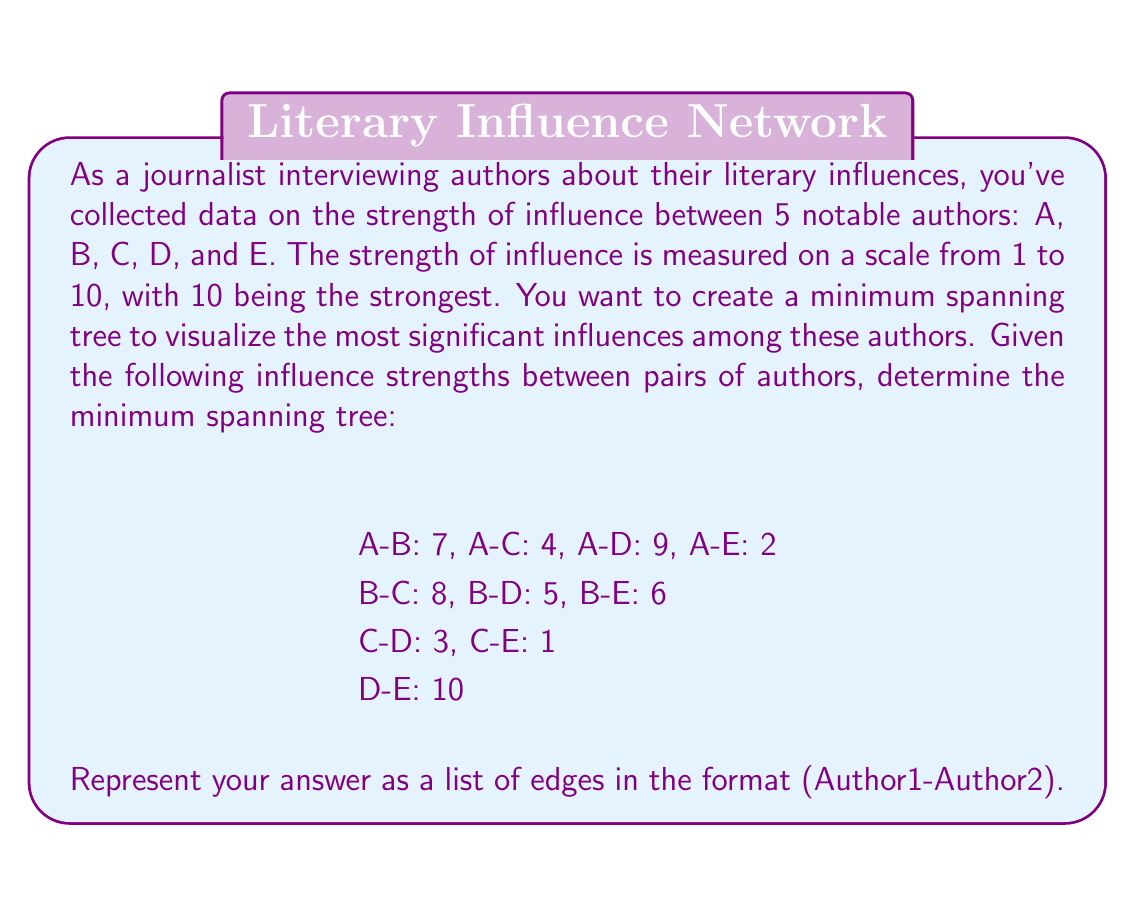Can you solve this math problem? To solve this problem, we'll use Kruskal's algorithm to find the minimum spanning tree (MST) of the graph representing the authors and their influences. Here's the step-by-step process:

1. Sort all edges in ascending order of weight (influence strength):
   C-E: 1
   A-E: 2
   C-D: 3
   A-C: 4
   B-D: 5
   B-E: 6
   A-B: 7
   B-C: 8
   A-D: 9
   D-E: 10

2. Initialize an empty set for the MST.

3. Iterate through the sorted edges:
   a) C-E: 1 - Add to MST
   b) A-E: 2 - Add to MST
   c) C-D: 3 - Add to MST
   d) A-C: 4 - Skip (would create a cycle)
   e) B-D: 5 - Add to MST
   f) B-E: 6 - Skip (would create a cycle)

4. Stop when we have $n-1 = 4$ edges in the MST, where $n = 5$ is the number of vertices.

The resulting minimum spanning tree consists of the edges:
C-E, A-E, C-D, B-D

This tree represents the most significant influences among the authors while minimizing the total strength of influence (which in this context means capturing the most direct and important connections).
Answer: The minimum spanning tree is: (C-E), (A-E), (C-D), (B-D) 